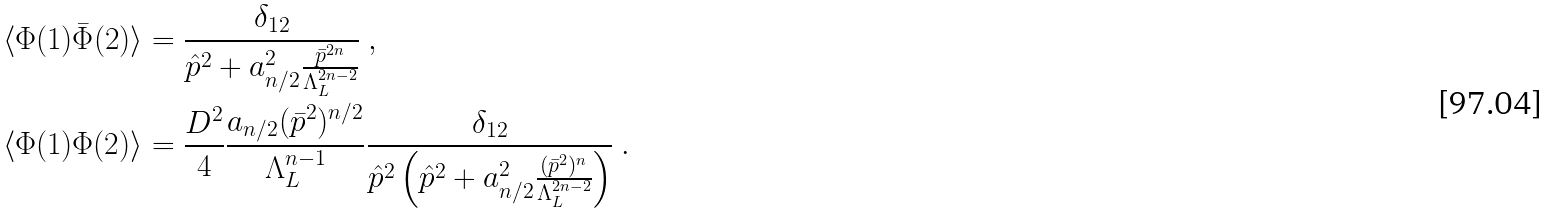<formula> <loc_0><loc_0><loc_500><loc_500>& \langle \Phi ( 1 ) \bar { \Phi } ( 2 ) \rangle = \frac { \delta _ { 1 2 } } { \hat { p } ^ { 2 } + a ^ { 2 } _ { n / 2 } \frac { \bar { p } ^ { 2 n } } { \Lambda _ { L } ^ { 2 n - 2 } } } \ , \\ & \langle \Phi ( 1 ) \Phi ( 2 ) \rangle = \frac { D ^ { 2 } } { 4 } \frac { a _ { n / 2 } ( \bar { p } ^ { 2 } ) ^ { n / 2 } } { \Lambda _ { L } ^ { n - 1 } } \frac { \delta _ { 1 2 } } { \hat { p } ^ { 2 } \left ( \hat { p } ^ { 2 } + a ^ { 2 } _ { n / 2 } \frac { ( \bar { p } ^ { 2 } ) ^ { n } } { \Lambda _ { L } ^ { 2 n - 2 } } \right ) } \ .</formula> 